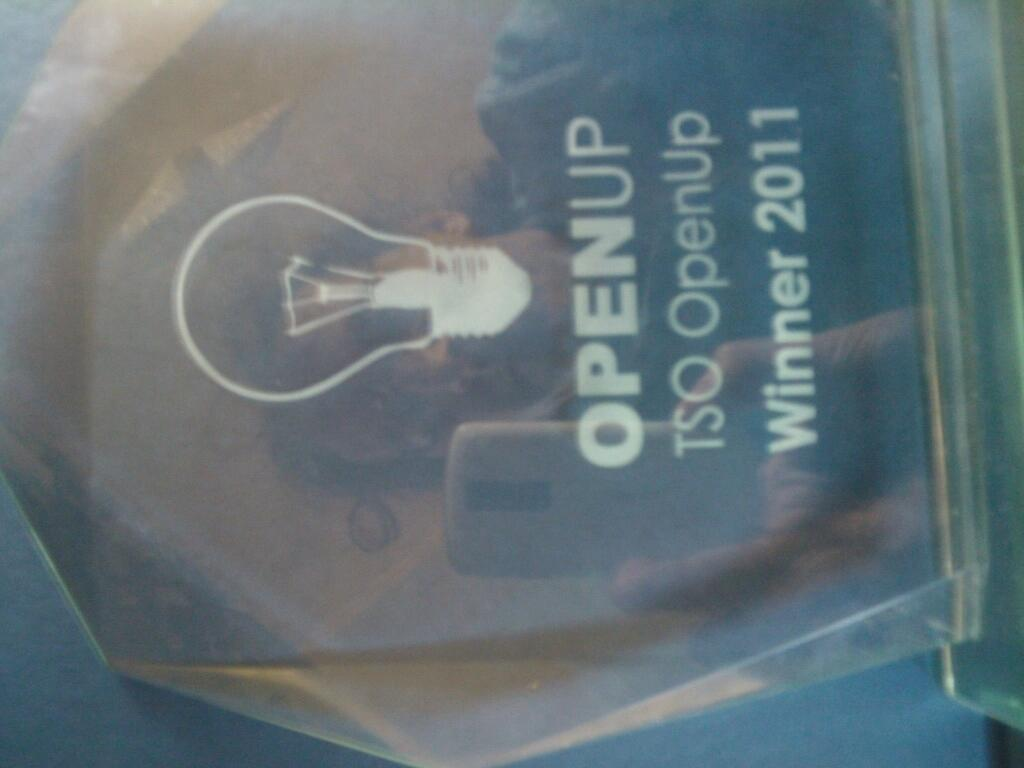<image>
Present a compact description of the photo's key features. An award with the words OpenUp winner 2011 on it. 